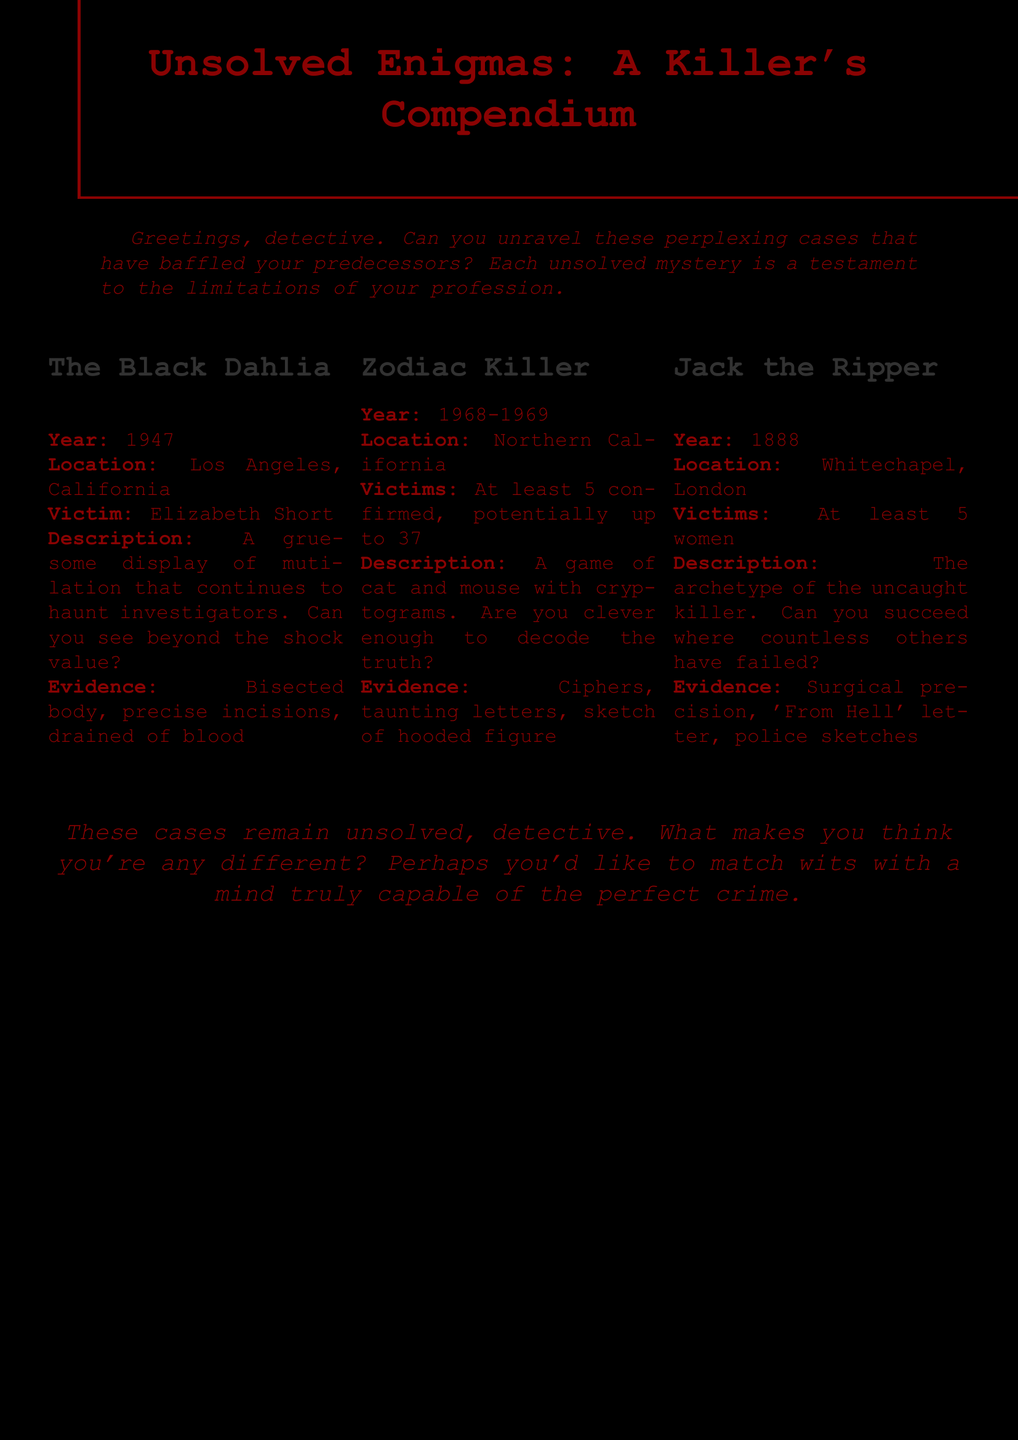What year did the Black Dahlia murder occur? The year of the Black Dahlia murder is clearly stated in the document.
Answer: 1947 How many confirmed victims did the Zodiac Killer have? The document specifies the number of confirmed victims under the Zodiac Killer section.
Answer: 5 What type of evidence was found in the Jack the Ripper case? The document lists specific evidence related to Jack the Ripper, pointing out surgical precision.
Answer: Surgical precision What unique feature is associated with the Zodiac Killer? The document describes a characteristic trait involving cryptograms tied to the Zodiac Killer.
Answer: Cryptograms In what city did the Black Dahlia murder take place? The location of the Black Dahlia murder is provided in the document under its description.
Answer: Los Angeles What is the challenge posed to the detective regarding the cases? The document concludes with a taunt about matching wits, reflecting the nature of the cases.
Answer: Match wits How many victims were there in the Jack the Ripper case? The document states the number of victims linked to Jack the Ripper in the description.
Answer: 5 women What does the 'From Hell' letter relate to? The document mentions this letter specifically in the context of the Jack the Ripper evidence.
Answer: Jack the Ripper What is the primary theme of the document? The document's title and content revolve around unsolved murder cases, highlighting unresolved mysteries.
Answer: Unsolved murder cases 